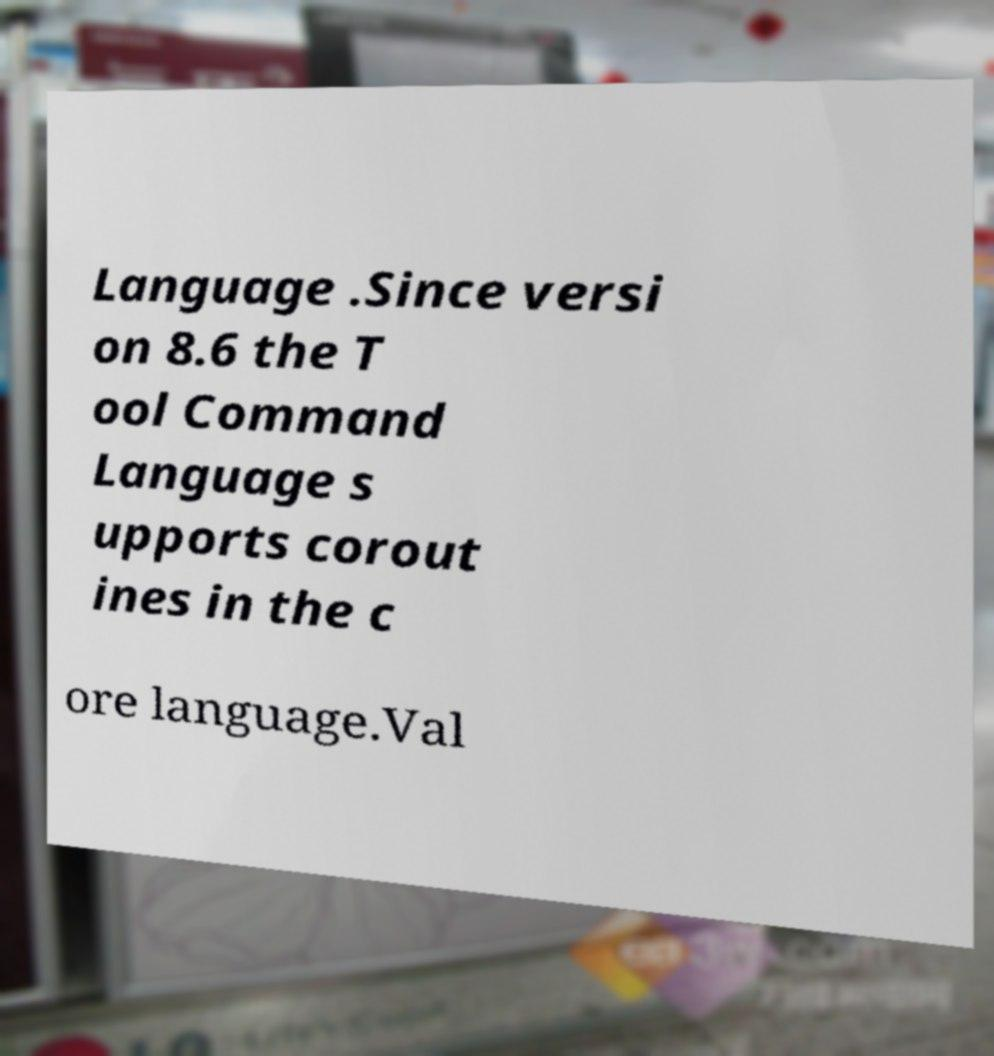There's text embedded in this image that I need extracted. Can you transcribe it verbatim? Language .Since versi on 8.6 the T ool Command Language s upports corout ines in the c ore language.Val 